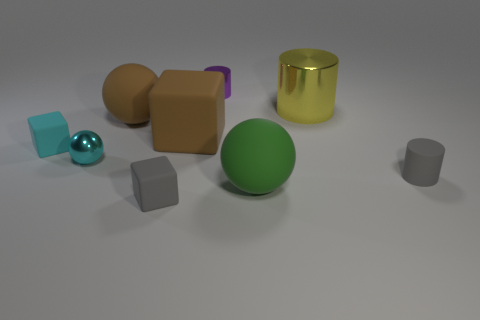Subtract all brown cubes. How many cubes are left? 2 Add 1 small metal cylinders. How many objects exist? 10 Subtract all purple cylinders. How many cylinders are left? 2 Subtract 0 yellow blocks. How many objects are left? 9 Subtract all blocks. How many objects are left? 6 Subtract 3 spheres. How many spheres are left? 0 Subtract all cyan cylinders. Subtract all yellow balls. How many cylinders are left? 3 Subtract all cyan cylinders. How many green spheres are left? 1 Subtract all large brown rubber cubes. Subtract all big yellow metal cylinders. How many objects are left? 7 Add 1 gray matte blocks. How many gray matte blocks are left? 2 